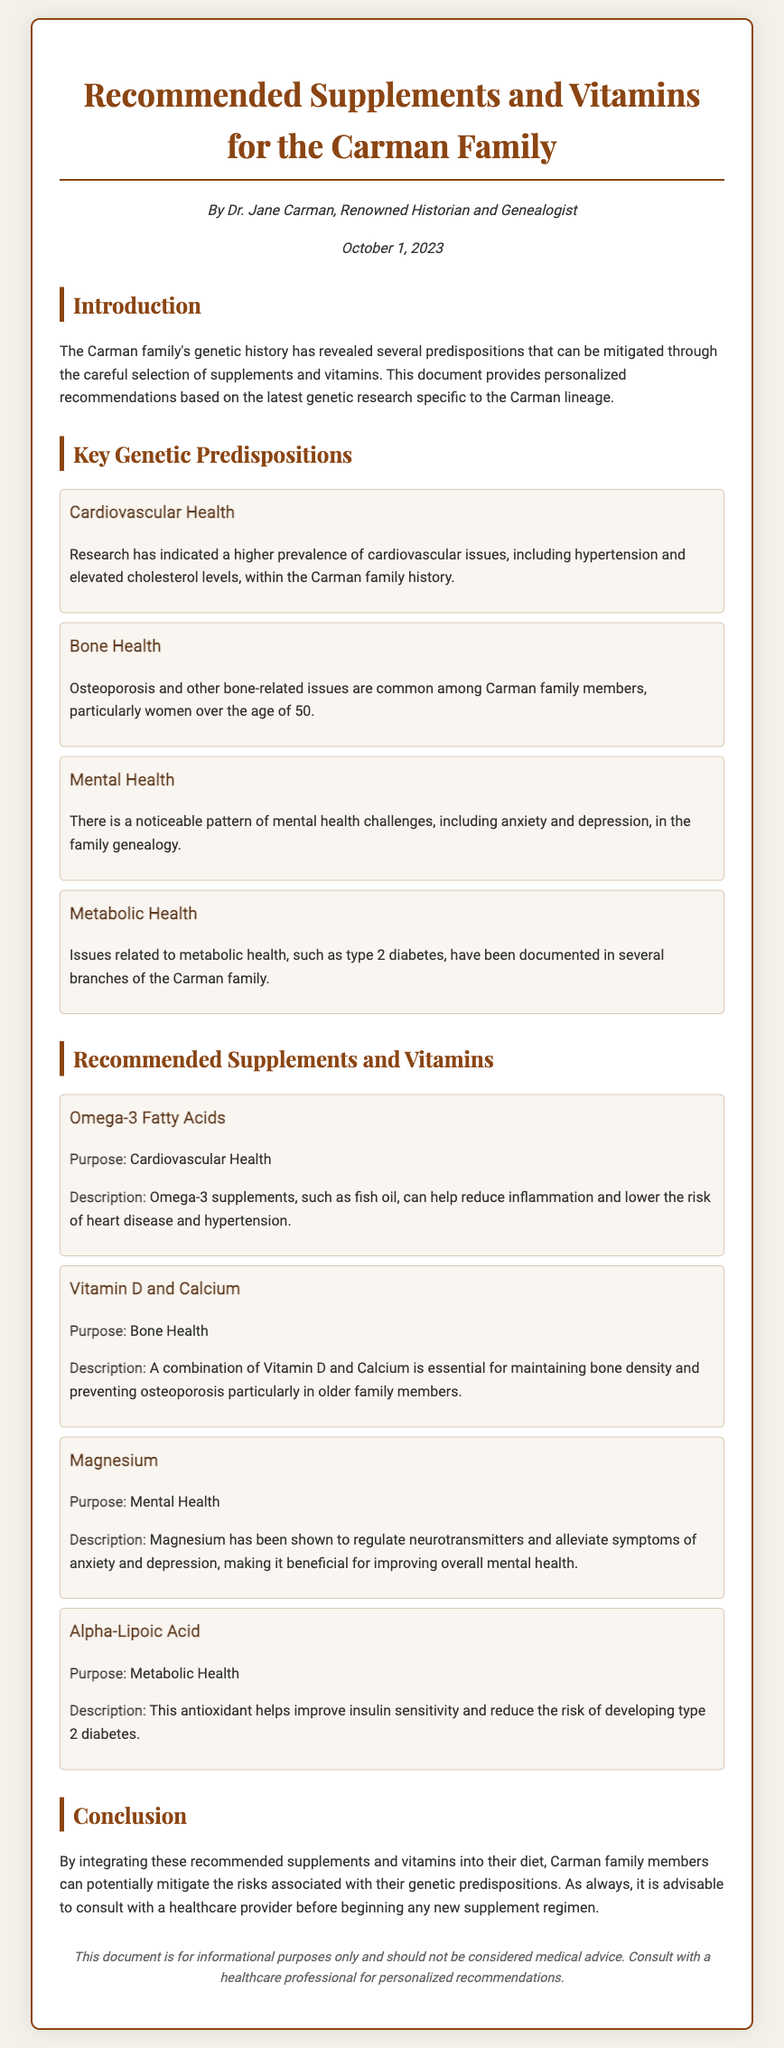What is the title of the document? The title is prominently displayed at the top of the document, indicating the subject matter of the recommendations.
Answer: Recommended Supplements and Vitamins for the Carman Family Who authored the document? The author's name is presented in the introduction section, indicating their credentials related to the content.
Answer: Dr. Jane Carman Which vitamin is recommended for bone health? This information is presented in the section outlining the recommended supplements, highlighting their purposes.
Answer: Vitamin D and Calcium What is the purpose of Omega-3 Fatty Acids? This encapsulates the specific health area that the supplement is intended to address, given in the description of the supplement.
Answer: Cardiovascular Health How many key genetic predispositions are mentioned? This number is found by totaling the distinct predispositions listed in the document.
Answer: Four What health issue is linked to magnesium? The document describes the benefits of magnesium in relation to a specific area of health.
Answer: Mental Health What is emphasized before starting any new supplement regimen? The document includes important advice regarding prior consultation, underscoring the need for professional guidance.
Answer: Consult with a healthcare provider 